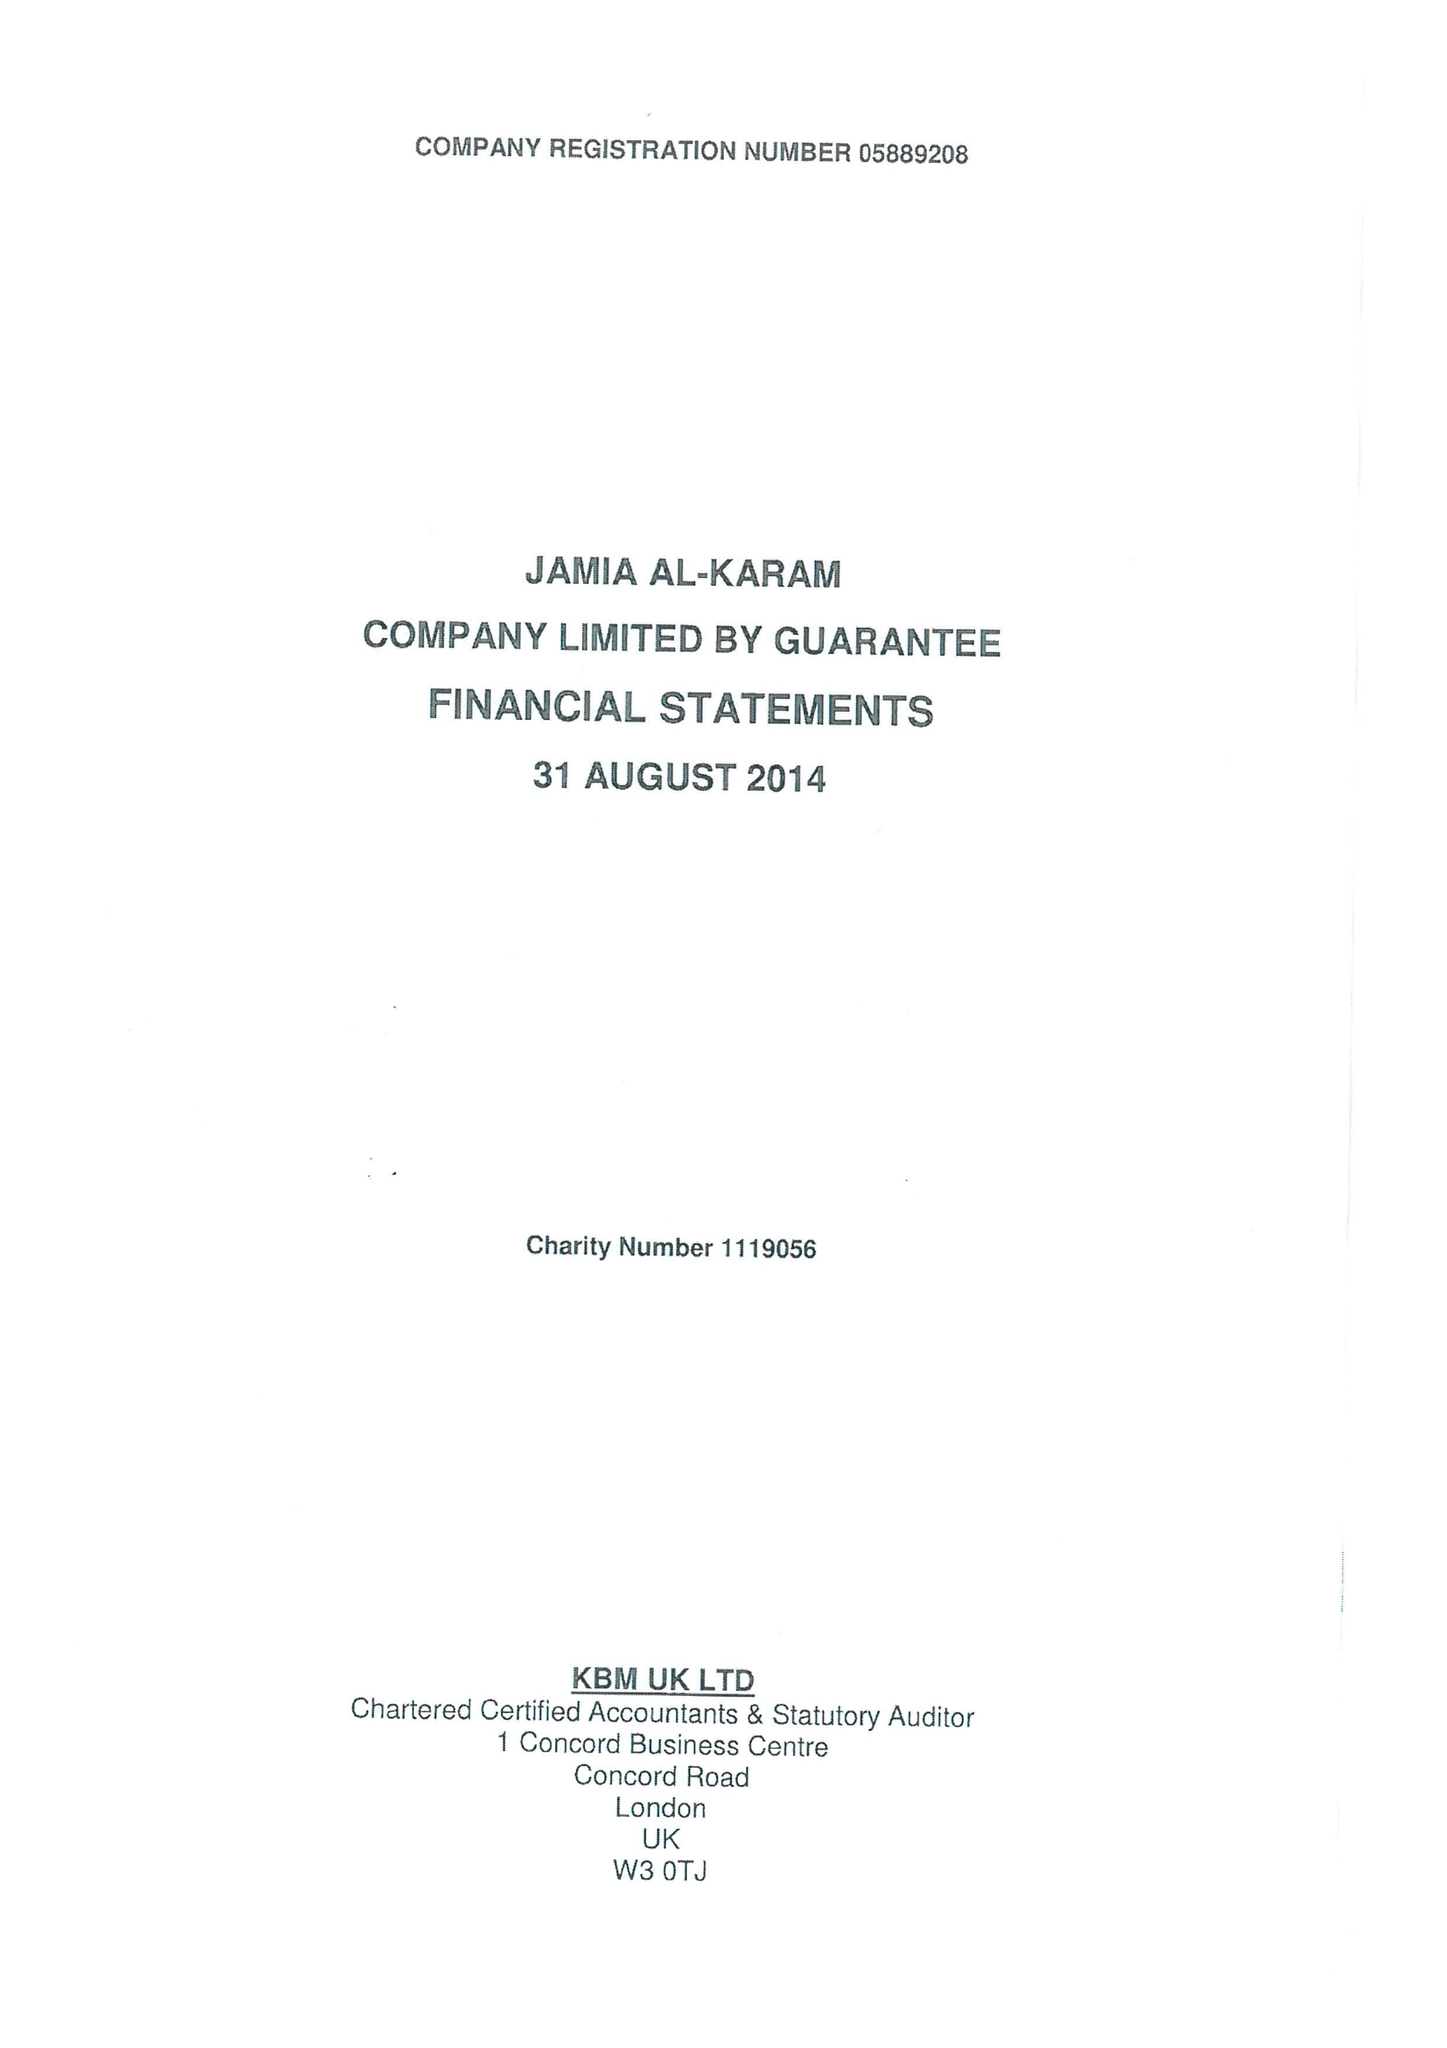What is the value for the charity_name?
Answer the question using a single word or phrase. Jamia Al-Karam 